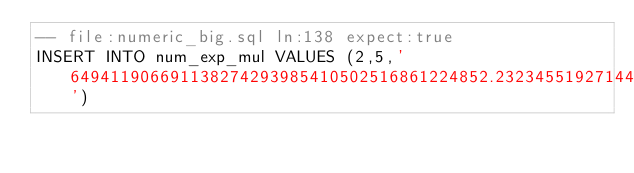<code> <loc_0><loc_0><loc_500><loc_500><_SQL_>-- file:numeric_big.sql ln:138 expect:true
INSERT INTO num_exp_mul VALUES (2,5,'649411906691138274293985410502516861224852.2323455192714410716272307781034189160865613770320102043319541634113746032638191509585045862973333645830298922352816245477556264222094036953195419857712804755170632292914187367964994214922001758104594052499795564860466055599417895782179851297585155129541589802249540436678824225950907268084876110445460948679383611117263673106597132046331719468816839434908155684738864149955129235751738204036443603521478609787295079710078973503970964790273461142497259987849074597264522099648376356902360358310245001183020992360260836105404118742418040965190000718736837422434593694808973939805954329718232693154128543253581495885789333274488461716809104532693754070810202831113003978085636579574171344721710232931261731022478029314435363413498991740750878099825781577297965642009156858479681236085226911858782115')
</code> 